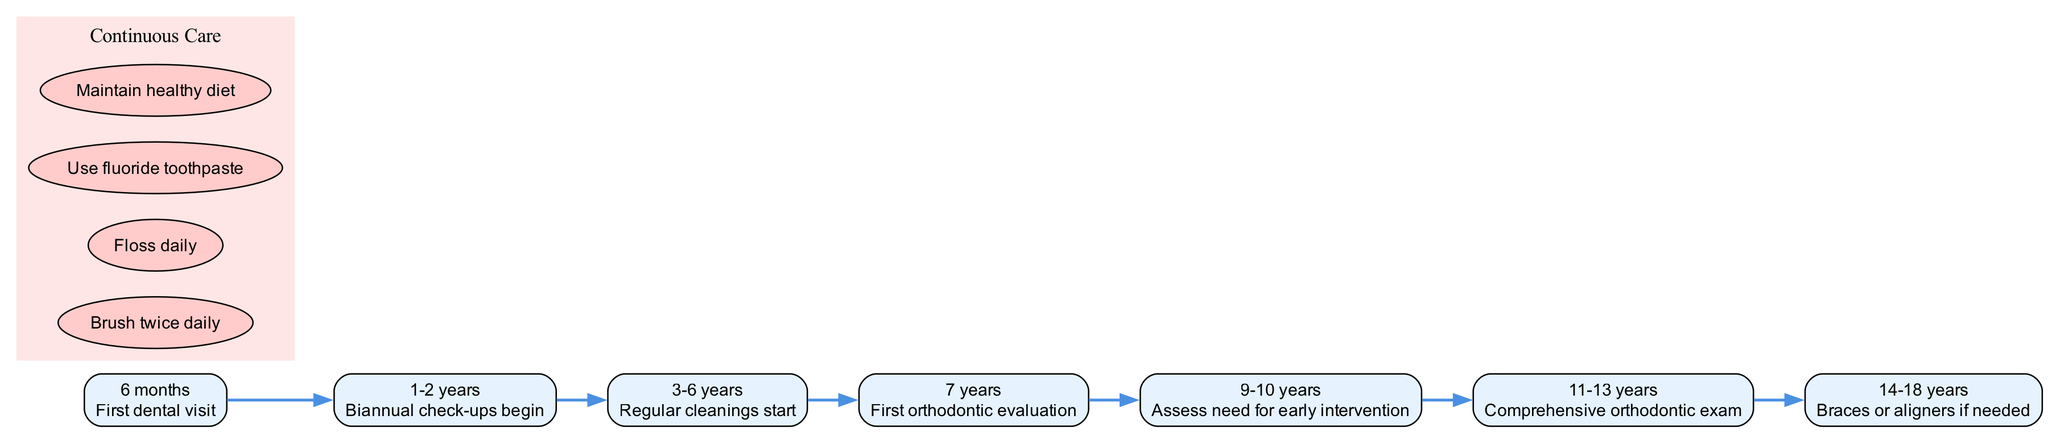What age is the first dental visit recommended? The diagram indicates that the first dental visit is recommended at 6 months of age. This information is clearly labeled in the timeline.
Answer: 6 months How many events are listed in the timeline? To find the number of events, count the individual entries in the timeline section of the diagram. There are seven specific events listed related to dental visits and orthodontic evaluations.
Answer: 7 What is the event that occurs at 11-13 years? At the age of 11-13 years, the diagram states that a comprehensive orthodontic exam takes place. This is specific information located in the timeline section.
Answer: Comprehensive orthodontic exam What is the continuous care recommendation concerning oral hygiene? The diagram provides several continuous care recommendations, and one of them is to brush twice daily. This is clearly stated under the continuous care section.
Answer: Brush twice daily At what age is the first orthodontic evaluation suggested? According to the timeline in the diagram, the first orthodontic evaluation is suggested at 7 years of age. This information is presented directly in the events section.
Answer: 7 years What age range indicates when to assess the need for early intervention? The diagram specifies that the assessment for early intervention should occur between the ages of 9 to 10 years. This information is represented in the timeline events.
Answer: 9-10 years How does the event at 3-6 years relate to continuous care? The event at 3-6 years indicates that regular cleanings start during this period, which ties into continuous care as it emphasizes the importance of maintaining oral hygiene, including regular check-ups. This reasoning combines the timeline event with the ongoing recommendations.
Answer: Regular cleanings What color signifies the continuous care section in the diagram? The continuous care section is filled with a light pink color (#FFE6E6), as indicated in the diagram's attributes for that specific subgraph.
Answer: Light pink What is the final orthodontic treatment option mentioned in the timeline? The timeline mentions that braces or aligners may be required if needed during the ages of 14 to 18 years. This information is the last event in the sequence, indicating a culmination of previous evaluations.
Answer: Braces or aligners if needed 